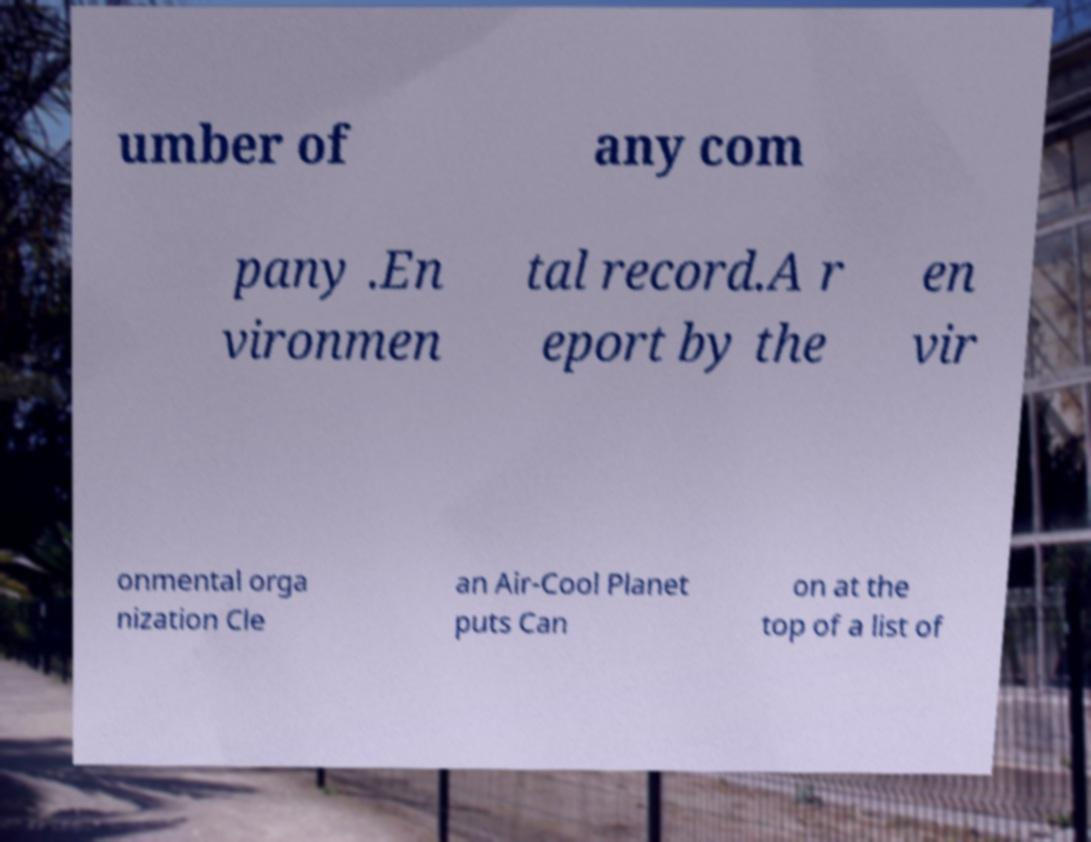Please identify and transcribe the text found in this image. umber of any com pany .En vironmen tal record.A r eport by the en vir onmental orga nization Cle an Air-Cool Planet puts Can on at the top of a list of 